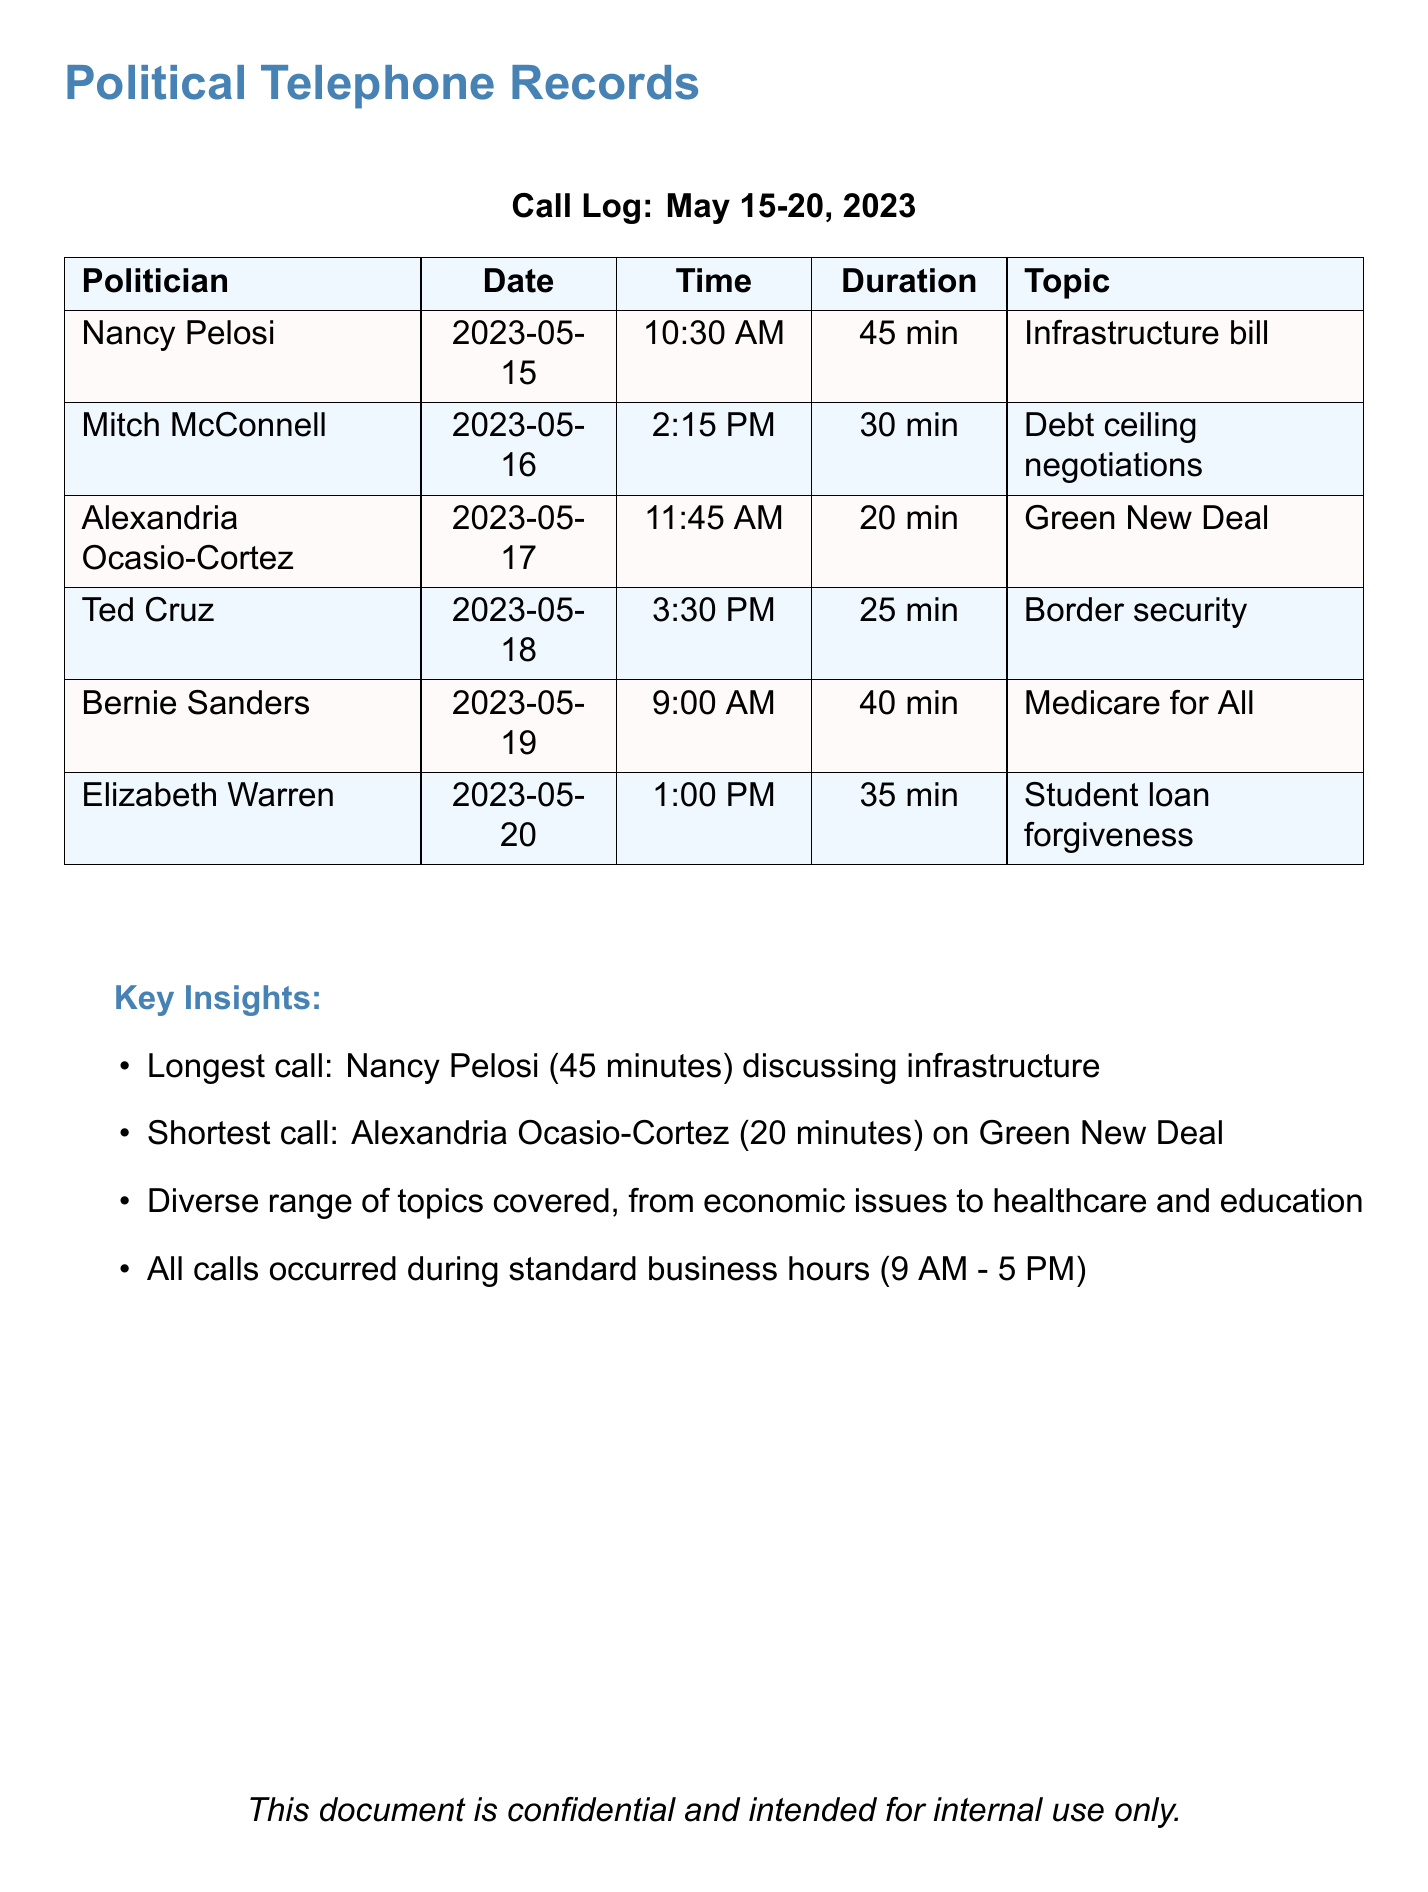What was the longest call duration? The longest call duration is highlighted in the key insights section of the document, specifically attributed to Nancy Pelosi's call.
Answer: 45 min Who discussed the Infrastructure bill? The call log indicates that Nancy Pelosi was the politician who discussed the Infrastructure bill.
Answer: Nancy Pelosi What date did Alexandria Ocasio-Cortez make her call? The date of Alexandria Ocasio-Cortez's call is specified in the call log under her name.
Answer: 2023-05-17 Which politician called regarding student loan forgiveness? The call log shows that Elizabeth Warren was the politician who discussed student loan forgiveness.
Answer: Elizabeth Warren What is the shortest call duration? The shortest call duration is noted in the key insights section as being associated with Alexandria Ocasio-Cortez.
Answer: 20 min What time did Ted Cruz's call take place? The specific time of Ted Cruz's call is listed in the call log beside his name.
Answer: 3:30 PM How many politicians were involved in the calls? The document lists a total of six different politicians in the call log.
Answer: 6 What was the main topic of Bernie Sanders' call? The main topic discussed during Bernie Sanders' call is stated clearly in the call log.
Answer: Medicare for All Did any calls occur after 5 PM? The document states that all calls took place during standard business hours, indicating none occurred after 5 PM.
Answer: No 